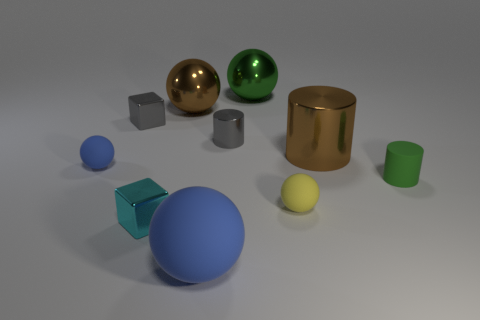Subtract all metallic cylinders. How many cylinders are left? 1 Subtract all blue blocks. How many blue spheres are left? 2 Subtract 3 balls. How many balls are left? 2 Subtract all blue spheres. How many spheres are left? 3 Subtract all cylinders. How many objects are left? 7 Subtract all blue cylinders. Subtract all brown blocks. How many cylinders are left? 3 Add 3 small cyan metallic objects. How many small cyan metallic objects are left? 4 Add 2 big purple matte blocks. How many big purple matte blocks exist? 2 Subtract 0 red blocks. How many objects are left? 10 Subtract all balls. Subtract all cyan blocks. How many objects are left? 4 